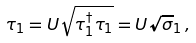Convert formula to latex. <formula><loc_0><loc_0><loc_500><loc_500>\tau _ { 1 } = U \sqrt { \tau _ { 1 } ^ { \dagger } \tau _ { 1 } } = U \sqrt { \sigma } _ { 1 } \, ,</formula> 